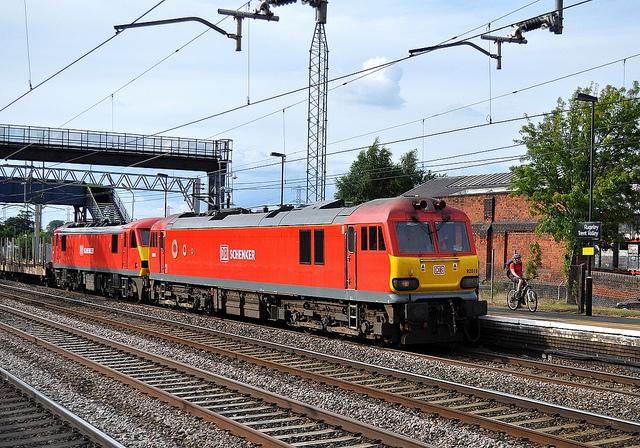What is the man riding?
Answer briefly. Bicycle. What is behind the train that has two wheels?
Answer briefly. Bicycle. Is this a freight train?
Answer briefly. Yes. How many tracks do you see?
Answer briefly. 4. What is said on the side of the train?
Concise answer only. Schenker. 